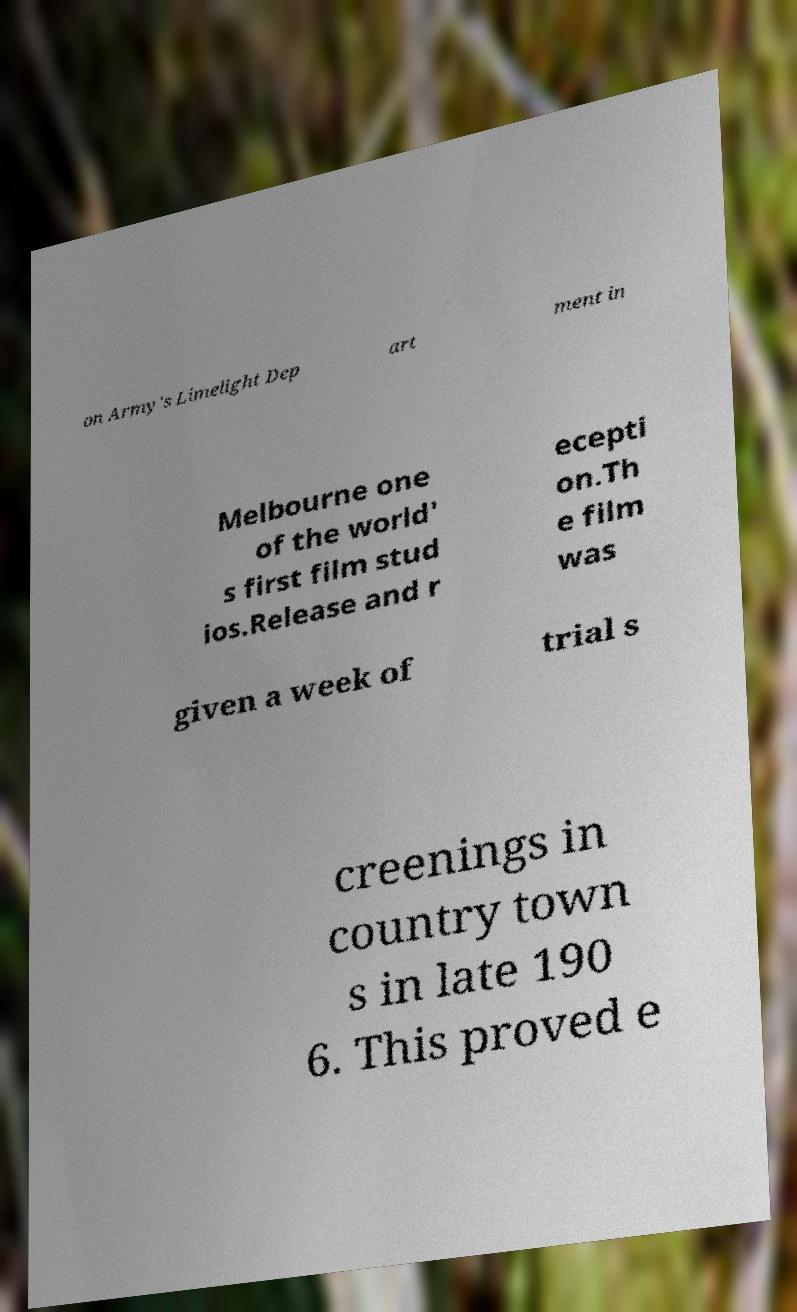Could you assist in decoding the text presented in this image and type it out clearly? on Army's Limelight Dep art ment in Melbourne one of the world' s first film stud ios.Release and r ecepti on.Th e film was given a week of trial s creenings in country town s in late 190 6. This proved e 